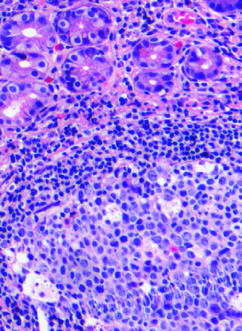what are characteristic of h. pylori gastritis?
Answer the question using a single word or phrase. Lymphoid aggregates with germinal centers and abundant subepithelial plasma cells within the superficial lamina propria 